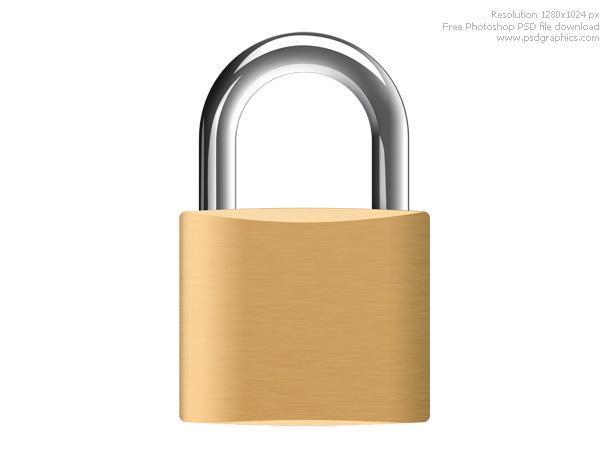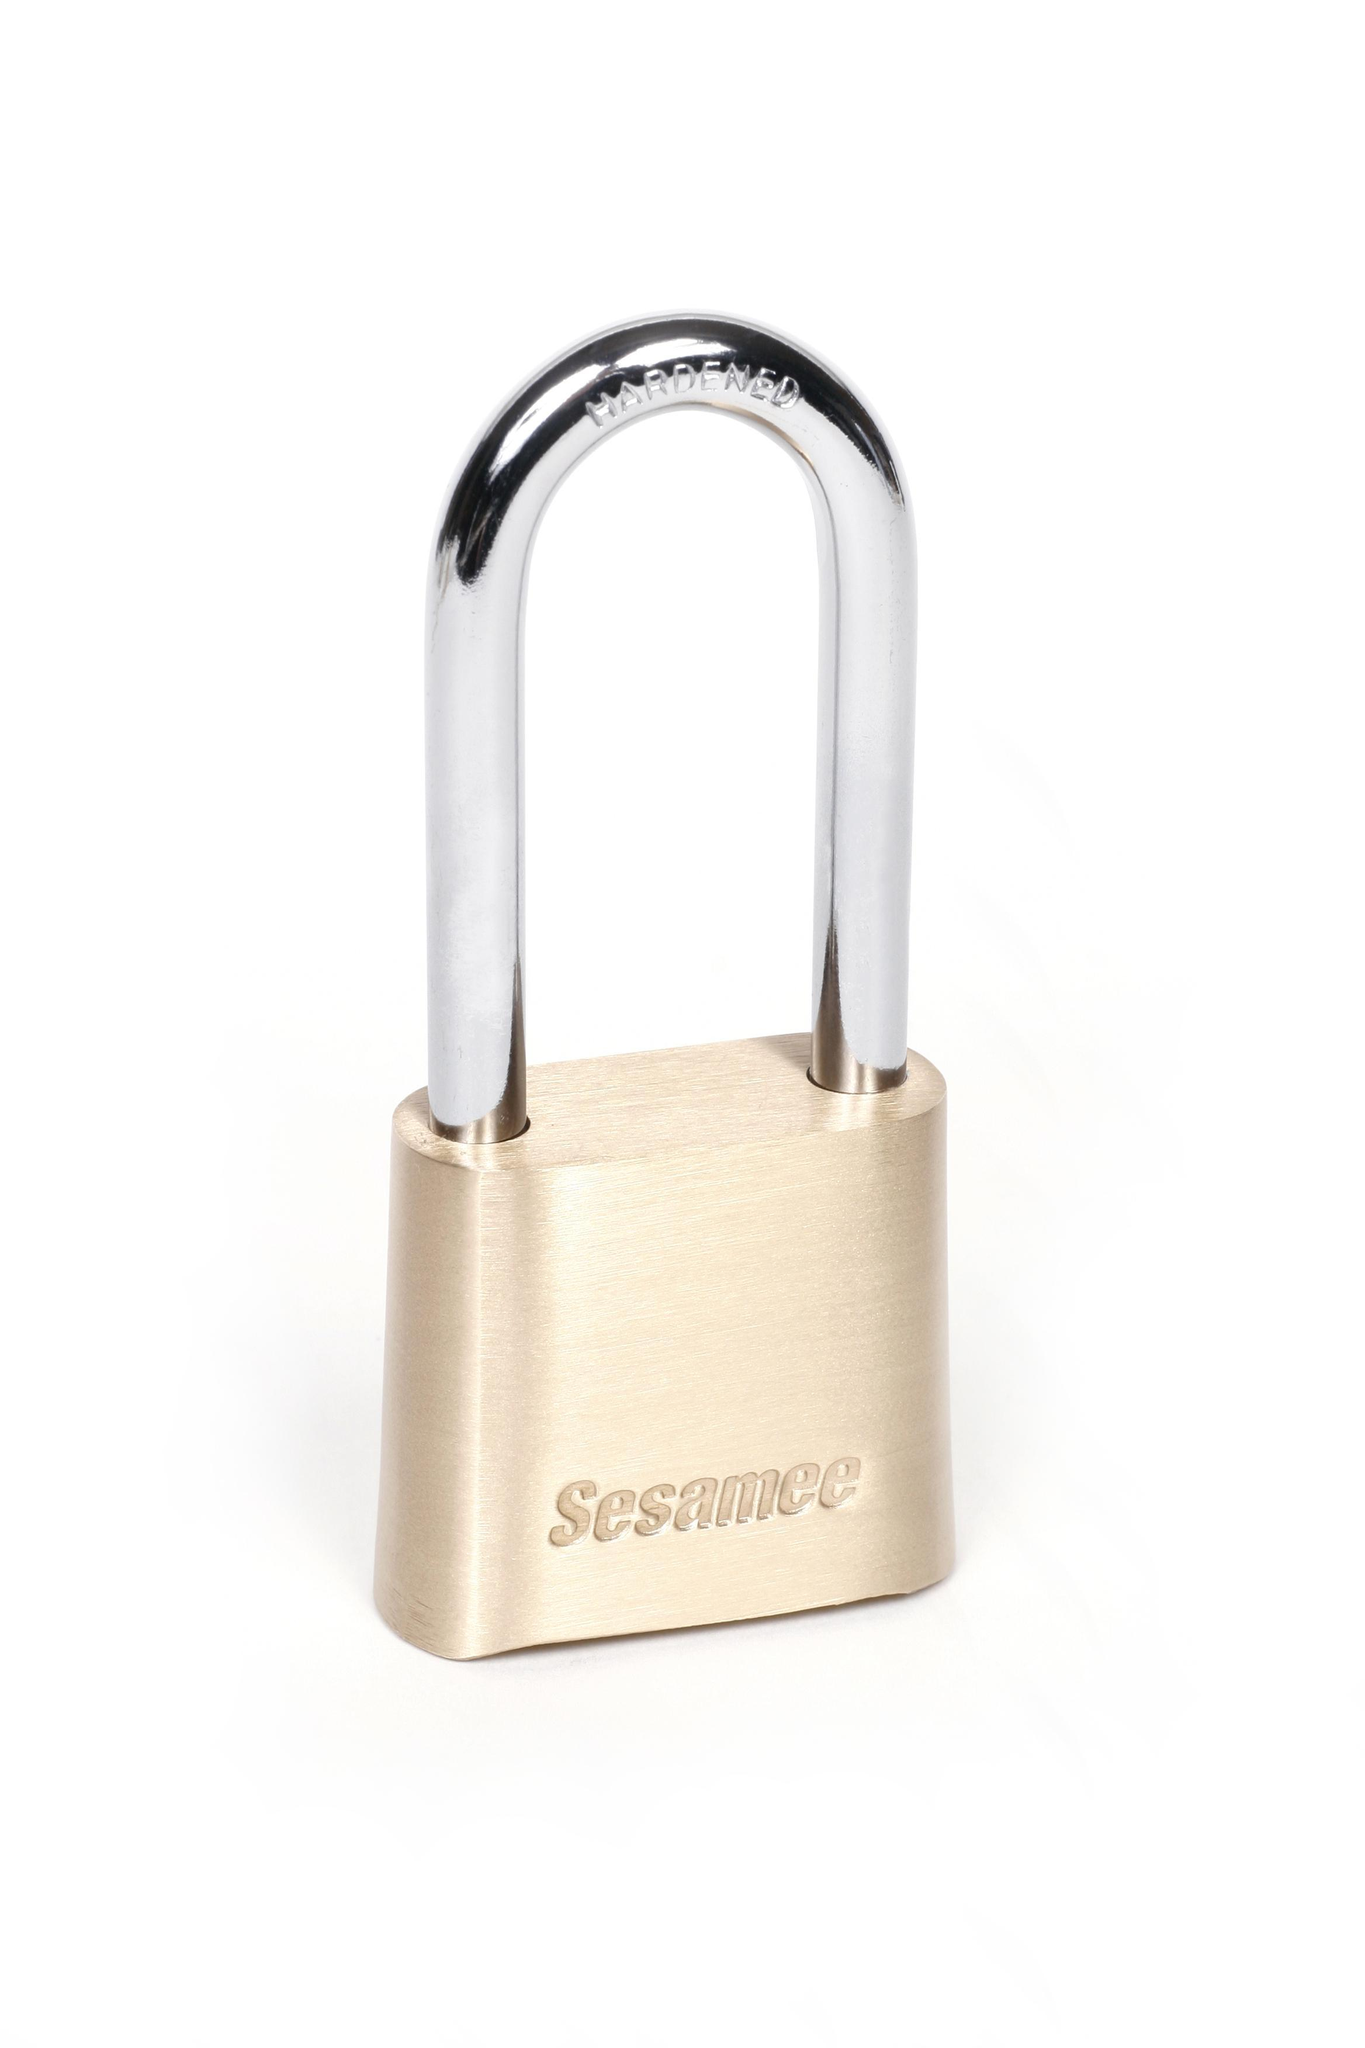The first image is the image on the left, the second image is the image on the right. Given the left and right images, does the statement "Two locks are both roughly square shaped, but the metal loop of one lock is much longer than the loop of the other lock." hold true? Answer yes or no. Yes. The first image is the image on the left, the second image is the image on the right. Evaluate the accuracy of this statement regarding the images: "The body of both locks is made of gold colored metal.". Is it true? Answer yes or no. Yes. 